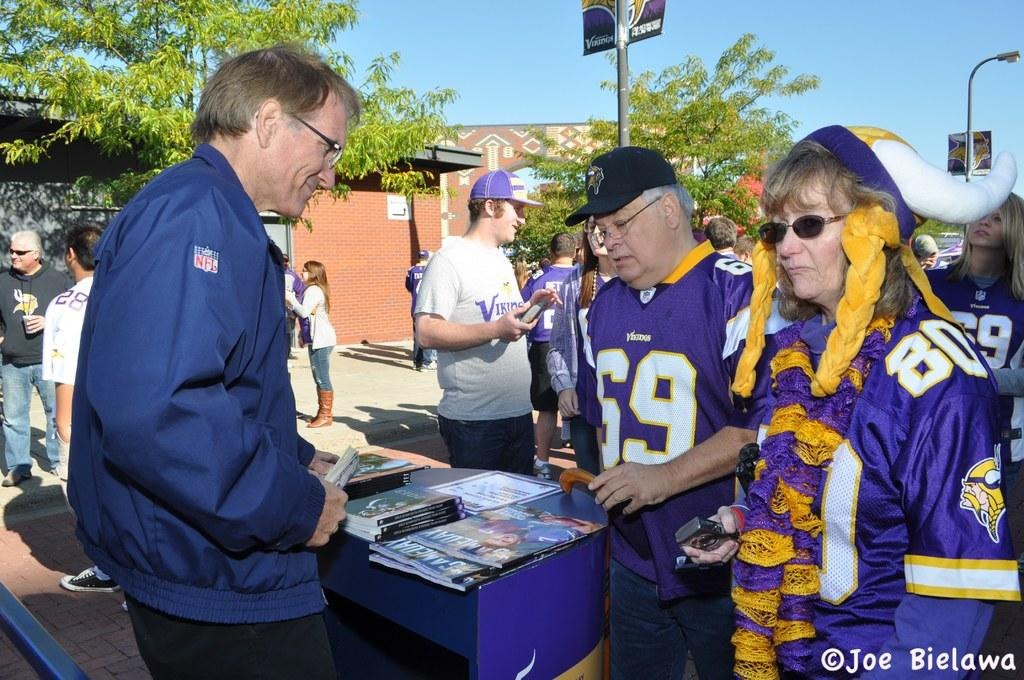<image>
Provide a brief description of the given image. The man in the middle is wearing the jersey number 69 